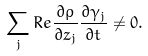<formula> <loc_0><loc_0><loc_500><loc_500>\sum _ { j } R e \frac { \partial \rho } { \partial z _ { j } } \frac { \partial \gamma _ { j } } { \partial t } \neq 0 .</formula> 